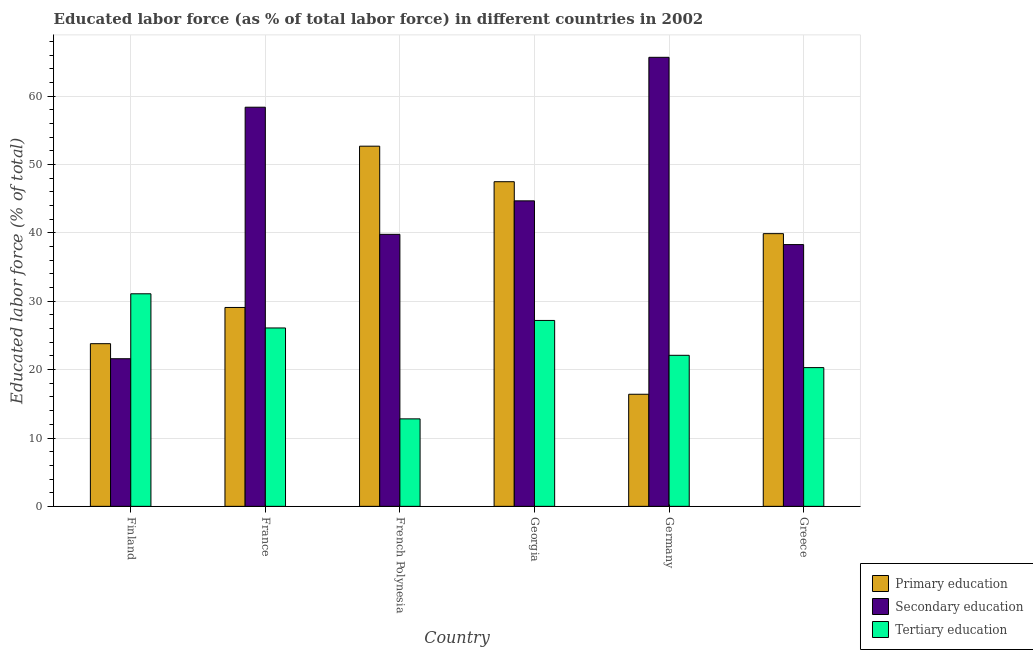How many different coloured bars are there?
Your response must be concise. 3. How many groups of bars are there?
Make the answer very short. 6. Are the number of bars on each tick of the X-axis equal?
Your response must be concise. Yes. What is the label of the 6th group of bars from the left?
Give a very brief answer. Greece. In how many cases, is the number of bars for a given country not equal to the number of legend labels?
Provide a short and direct response. 0. What is the percentage of labor force who received secondary education in French Polynesia?
Provide a short and direct response. 39.8. Across all countries, what is the maximum percentage of labor force who received primary education?
Give a very brief answer. 52.7. Across all countries, what is the minimum percentage of labor force who received secondary education?
Provide a succinct answer. 21.6. In which country was the percentage of labor force who received primary education maximum?
Offer a very short reply. French Polynesia. In which country was the percentage of labor force who received secondary education minimum?
Your response must be concise. Finland. What is the total percentage of labor force who received primary education in the graph?
Offer a terse response. 209.4. What is the difference between the percentage of labor force who received tertiary education in France and that in Georgia?
Provide a short and direct response. -1.1. What is the difference between the percentage of labor force who received tertiary education in Germany and the percentage of labor force who received primary education in Finland?
Provide a succinct answer. -1.7. What is the average percentage of labor force who received secondary education per country?
Offer a terse response. 44.75. What is the difference between the percentage of labor force who received tertiary education and percentage of labor force who received primary education in French Polynesia?
Offer a very short reply. -39.9. What is the ratio of the percentage of labor force who received secondary education in Finland to that in France?
Give a very brief answer. 0.37. What is the difference between the highest and the second highest percentage of labor force who received primary education?
Keep it short and to the point. 5.2. What is the difference between the highest and the lowest percentage of labor force who received tertiary education?
Your response must be concise. 18.3. Is the sum of the percentage of labor force who received primary education in Finland and Germany greater than the maximum percentage of labor force who received secondary education across all countries?
Provide a short and direct response. No. What does the 2nd bar from the left in France represents?
Offer a terse response. Secondary education. What does the 3rd bar from the right in Greece represents?
Provide a succinct answer. Primary education. Is it the case that in every country, the sum of the percentage of labor force who received primary education and percentage of labor force who received secondary education is greater than the percentage of labor force who received tertiary education?
Your response must be concise. Yes. How many bars are there?
Provide a succinct answer. 18. How many countries are there in the graph?
Offer a terse response. 6. What is the difference between two consecutive major ticks on the Y-axis?
Offer a terse response. 10. How are the legend labels stacked?
Your response must be concise. Vertical. What is the title of the graph?
Provide a succinct answer. Educated labor force (as % of total labor force) in different countries in 2002. Does "Ages 15-64" appear as one of the legend labels in the graph?
Your response must be concise. No. What is the label or title of the X-axis?
Provide a succinct answer. Country. What is the label or title of the Y-axis?
Give a very brief answer. Educated labor force (% of total). What is the Educated labor force (% of total) of Primary education in Finland?
Make the answer very short. 23.8. What is the Educated labor force (% of total) of Secondary education in Finland?
Make the answer very short. 21.6. What is the Educated labor force (% of total) in Tertiary education in Finland?
Offer a terse response. 31.1. What is the Educated labor force (% of total) in Primary education in France?
Provide a short and direct response. 29.1. What is the Educated labor force (% of total) in Secondary education in France?
Offer a very short reply. 58.4. What is the Educated labor force (% of total) of Tertiary education in France?
Your answer should be compact. 26.1. What is the Educated labor force (% of total) of Primary education in French Polynesia?
Give a very brief answer. 52.7. What is the Educated labor force (% of total) of Secondary education in French Polynesia?
Provide a short and direct response. 39.8. What is the Educated labor force (% of total) of Tertiary education in French Polynesia?
Keep it short and to the point. 12.8. What is the Educated labor force (% of total) of Primary education in Georgia?
Your answer should be very brief. 47.5. What is the Educated labor force (% of total) in Secondary education in Georgia?
Make the answer very short. 44.7. What is the Educated labor force (% of total) of Tertiary education in Georgia?
Give a very brief answer. 27.2. What is the Educated labor force (% of total) of Primary education in Germany?
Offer a very short reply. 16.4. What is the Educated labor force (% of total) in Secondary education in Germany?
Offer a terse response. 65.7. What is the Educated labor force (% of total) of Tertiary education in Germany?
Make the answer very short. 22.1. What is the Educated labor force (% of total) in Primary education in Greece?
Your response must be concise. 39.9. What is the Educated labor force (% of total) in Secondary education in Greece?
Give a very brief answer. 38.3. What is the Educated labor force (% of total) of Tertiary education in Greece?
Provide a succinct answer. 20.3. Across all countries, what is the maximum Educated labor force (% of total) in Primary education?
Make the answer very short. 52.7. Across all countries, what is the maximum Educated labor force (% of total) of Secondary education?
Provide a succinct answer. 65.7. Across all countries, what is the maximum Educated labor force (% of total) in Tertiary education?
Keep it short and to the point. 31.1. Across all countries, what is the minimum Educated labor force (% of total) of Primary education?
Your answer should be very brief. 16.4. Across all countries, what is the minimum Educated labor force (% of total) of Secondary education?
Keep it short and to the point. 21.6. Across all countries, what is the minimum Educated labor force (% of total) of Tertiary education?
Offer a very short reply. 12.8. What is the total Educated labor force (% of total) in Primary education in the graph?
Provide a succinct answer. 209.4. What is the total Educated labor force (% of total) of Secondary education in the graph?
Provide a short and direct response. 268.5. What is the total Educated labor force (% of total) in Tertiary education in the graph?
Offer a very short reply. 139.6. What is the difference between the Educated labor force (% of total) in Primary education in Finland and that in France?
Make the answer very short. -5.3. What is the difference between the Educated labor force (% of total) in Secondary education in Finland and that in France?
Make the answer very short. -36.8. What is the difference between the Educated labor force (% of total) in Tertiary education in Finland and that in France?
Give a very brief answer. 5. What is the difference between the Educated labor force (% of total) in Primary education in Finland and that in French Polynesia?
Provide a succinct answer. -28.9. What is the difference between the Educated labor force (% of total) of Secondary education in Finland and that in French Polynesia?
Ensure brevity in your answer.  -18.2. What is the difference between the Educated labor force (% of total) of Primary education in Finland and that in Georgia?
Offer a very short reply. -23.7. What is the difference between the Educated labor force (% of total) of Secondary education in Finland and that in Georgia?
Provide a short and direct response. -23.1. What is the difference between the Educated labor force (% of total) in Primary education in Finland and that in Germany?
Your answer should be compact. 7.4. What is the difference between the Educated labor force (% of total) of Secondary education in Finland and that in Germany?
Make the answer very short. -44.1. What is the difference between the Educated labor force (% of total) in Tertiary education in Finland and that in Germany?
Keep it short and to the point. 9. What is the difference between the Educated labor force (% of total) in Primary education in Finland and that in Greece?
Give a very brief answer. -16.1. What is the difference between the Educated labor force (% of total) in Secondary education in Finland and that in Greece?
Provide a succinct answer. -16.7. What is the difference between the Educated labor force (% of total) in Tertiary education in Finland and that in Greece?
Keep it short and to the point. 10.8. What is the difference between the Educated labor force (% of total) of Primary education in France and that in French Polynesia?
Offer a very short reply. -23.6. What is the difference between the Educated labor force (% of total) of Tertiary education in France and that in French Polynesia?
Your answer should be very brief. 13.3. What is the difference between the Educated labor force (% of total) of Primary education in France and that in Georgia?
Provide a short and direct response. -18.4. What is the difference between the Educated labor force (% of total) of Secondary education in France and that in Georgia?
Your response must be concise. 13.7. What is the difference between the Educated labor force (% of total) in Tertiary education in France and that in Georgia?
Your response must be concise. -1.1. What is the difference between the Educated labor force (% of total) of Secondary education in France and that in Germany?
Give a very brief answer. -7.3. What is the difference between the Educated labor force (% of total) of Tertiary education in France and that in Germany?
Offer a very short reply. 4. What is the difference between the Educated labor force (% of total) in Primary education in France and that in Greece?
Your answer should be compact. -10.8. What is the difference between the Educated labor force (% of total) in Secondary education in France and that in Greece?
Provide a short and direct response. 20.1. What is the difference between the Educated labor force (% of total) of Secondary education in French Polynesia and that in Georgia?
Offer a terse response. -4.9. What is the difference between the Educated labor force (% of total) of Tertiary education in French Polynesia and that in Georgia?
Provide a succinct answer. -14.4. What is the difference between the Educated labor force (% of total) in Primary education in French Polynesia and that in Germany?
Offer a terse response. 36.3. What is the difference between the Educated labor force (% of total) in Secondary education in French Polynesia and that in Germany?
Your answer should be compact. -25.9. What is the difference between the Educated labor force (% of total) of Tertiary education in French Polynesia and that in Germany?
Ensure brevity in your answer.  -9.3. What is the difference between the Educated labor force (% of total) of Primary education in French Polynesia and that in Greece?
Ensure brevity in your answer.  12.8. What is the difference between the Educated labor force (% of total) in Secondary education in French Polynesia and that in Greece?
Your response must be concise. 1.5. What is the difference between the Educated labor force (% of total) of Primary education in Georgia and that in Germany?
Offer a very short reply. 31.1. What is the difference between the Educated labor force (% of total) of Secondary education in Georgia and that in Germany?
Provide a short and direct response. -21. What is the difference between the Educated labor force (% of total) of Secondary education in Georgia and that in Greece?
Give a very brief answer. 6.4. What is the difference between the Educated labor force (% of total) in Primary education in Germany and that in Greece?
Provide a succinct answer. -23.5. What is the difference between the Educated labor force (% of total) in Secondary education in Germany and that in Greece?
Provide a short and direct response. 27.4. What is the difference between the Educated labor force (% of total) of Tertiary education in Germany and that in Greece?
Ensure brevity in your answer.  1.8. What is the difference between the Educated labor force (% of total) of Primary education in Finland and the Educated labor force (% of total) of Secondary education in France?
Provide a short and direct response. -34.6. What is the difference between the Educated labor force (% of total) of Primary education in Finland and the Educated labor force (% of total) of Tertiary education in France?
Make the answer very short. -2.3. What is the difference between the Educated labor force (% of total) of Secondary education in Finland and the Educated labor force (% of total) of Tertiary education in France?
Your response must be concise. -4.5. What is the difference between the Educated labor force (% of total) in Primary education in Finland and the Educated labor force (% of total) in Tertiary education in French Polynesia?
Provide a succinct answer. 11. What is the difference between the Educated labor force (% of total) of Primary education in Finland and the Educated labor force (% of total) of Secondary education in Georgia?
Offer a terse response. -20.9. What is the difference between the Educated labor force (% of total) of Primary education in Finland and the Educated labor force (% of total) of Tertiary education in Georgia?
Make the answer very short. -3.4. What is the difference between the Educated labor force (% of total) of Primary education in Finland and the Educated labor force (% of total) of Secondary education in Germany?
Your answer should be compact. -41.9. What is the difference between the Educated labor force (% of total) of Primary education in Finland and the Educated labor force (% of total) of Tertiary education in Germany?
Offer a very short reply. 1.7. What is the difference between the Educated labor force (% of total) of Primary education in Finland and the Educated labor force (% of total) of Tertiary education in Greece?
Provide a succinct answer. 3.5. What is the difference between the Educated labor force (% of total) of Primary education in France and the Educated labor force (% of total) of Tertiary education in French Polynesia?
Make the answer very short. 16.3. What is the difference between the Educated labor force (% of total) of Secondary education in France and the Educated labor force (% of total) of Tertiary education in French Polynesia?
Give a very brief answer. 45.6. What is the difference between the Educated labor force (% of total) in Primary education in France and the Educated labor force (% of total) in Secondary education in Georgia?
Your response must be concise. -15.6. What is the difference between the Educated labor force (% of total) of Secondary education in France and the Educated labor force (% of total) of Tertiary education in Georgia?
Make the answer very short. 31.2. What is the difference between the Educated labor force (% of total) of Primary education in France and the Educated labor force (% of total) of Secondary education in Germany?
Your answer should be compact. -36.6. What is the difference between the Educated labor force (% of total) in Secondary education in France and the Educated labor force (% of total) in Tertiary education in Germany?
Keep it short and to the point. 36.3. What is the difference between the Educated labor force (% of total) of Primary education in France and the Educated labor force (% of total) of Tertiary education in Greece?
Your answer should be very brief. 8.8. What is the difference between the Educated labor force (% of total) in Secondary education in France and the Educated labor force (% of total) in Tertiary education in Greece?
Ensure brevity in your answer.  38.1. What is the difference between the Educated labor force (% of total) in Primary education in French Polynesia and the Educated labor force (% of total) in Secondary education in Georgia?
Your answer should be very brief. 8. What is the difference between the Educated labor force (% of total) in Primary education in French Polynesia and the Educated labor force (% of total) in Tertiary education in Georgia?
Your answer should be compact. 25.5. What is the difference between the Educated labor force (% of total) in Primary education in French Polynesia and the Educated labor force (% of total) in Tertiary education in Germany?
Your response must be concise. 30.6. What is the difference between the Educated labor force (% of total) in Primary education in French Polynesia and the Educated labor force (% of total) in Tertiary education in Greece?
Provide a short and direct response. 32.4. What is the difference between the Educated labor force (% of total) in Secondary education in French Polynesia and the Educated labor force (% of total) in Tertiary education in Greece?
Keep it short and to the point. 19.5. What is the difference between the Educated labor force (% of total) of Primary education in Georgia and the Educated labor force (% of total) of Secondary education in Germany?
Provide a succinct answer. -18.2. What is the difference between the Educated labor force (% of total) in Primary education in Georgia and the Educated labor force (% of total) in Tertiary education in Germany?
Provide a succinct answer. 25.4. What is the difference between the Educated labor force (% of total) of Secondary education in Georgia and the Educated labor force (% of total) of Tertiary education in Germany?
Give a very brief answer. 22.6. What is the difference between the Educated labor force (% of total) in Primary education in Georgia and the Educated labor force (% of total) in Tertiary education in Greece?
Give a very brief answer. 27.2. What is the difference between the Educated labor force (% of total) in Secondary education in Georgia and the Educated labor force (% of total) in Tertiary education in Greece?
Give a very brief answer. 24.4. What is the difference between the Educated labor force (% of total) in Primary education in Germany and the Educated labor force (% of total) in Secondary education in Greece?
Your answer should be very brief. -21.9. What is the difference between the Educated labor force (% of total) of Secondary education in Germany and the Educated labor force (% of total) of Tertiary education in Greece?
Provide a succinct answer. 45.4. What is the average Educated labor force (% of total) in Primary education per country?
Make the answer very short. 34.9. What is the average Educated labor force (% of total) in Secondary education per country?
Offer a very short reply. 44.75. What is the average Educated labor force (% of total) of Tertiary education per country?
Provide a succinct answer. 23.27. What is the difference between the Educated labor force (% of total) in Primary education and Educated labor force (% of total) in Secondary education in Finland?
Give a very brief answer. 2.2. What is the difference between the Educated labor force (% of total) of Primary education and Educated labor force (% of total) of Secondary education in France?
Give a very brief answer. -29.3. What is the difference between the Educated labor force (% of total) in Secondary education and Educated labor force (% of total) in Tertiary education in France?
Give a very brief answer. 32.3. What is the difference between the Educated labor force (% of total) of Primary education and Educated labor force (% of total) of Tertiary education in French Polynesia?
Your answer should be compact. 39.9. What is the difference between the Educated labor force (% of total) of Secondary education and Educated labor force (% of total) of Tertiary education in French Polynesia?
Provide a succinct answer. 27. What is the difference between the Educated labor force (% of total) of Primary education and Educated labor force (% of total) of Secondary education in Georgia?
Your answer should be very brief. 2.8. What is the difference between the Educated labor force (% of total) of Primary education and Educated labor force (% of total) of Tertiary education in Georgia?
Provide a short and direct response. 20.3. What is the difference between the Educated labor force (% of total) in Secondary education and Educated labor force (% of total) in Tertiary education in Georgia?
Give a very brief answer. 17.5. What is the difference between the Educated labor force (% of total) in Primary education and Educated labor force (% of total) in Secondary education in Germany?
Make the answer very short. -49.3. What is the difference between the Educated labor force (% of total) in Secondary education and Educated labor force (% of total) in Tertiary education in Germany?
Keep it short and to the point. 43.6. What is the difference between the Educated labor force (% of total) of Primary education and Educated labor force (% of total) of Secondary education in Greece?
Make the answer very short. 1.6. What is the difference between the Educated labor force (% of total) in Primary education and Educated labor force (% of total) in Tertiary education in Greece?
Provide a succinct answer. 19.6. What is the difference between the Educated labor force (% of total) in Secondary education and Educated labor force (% of total) in Tertiary education in Greece?
Provide a succinct answer. 18. What is the ratio of the Educated labor force (% of total) in Primary education in Finland to that in France?
Keep it short and to the point. 0.82. What is the ratio of the Educated labor force (% of total) in Secondary education in Finland to that in France?
Make the answer very short. 0.37. What is the ratio of the Educated labor force (% of total) of Tertiary education in Finland to that in France?
Make the answer very short. 1.19. What is the ratio of the Educated labor force (% of total) in Primary education in Finland to that in French Polynesia?
Give a very brief answer. 0.45. What is the ratio of the Educated labor force (% of total) in Secondary education in Finland to that in French Polynesia?
Ensure brevity in your answer.  0.54. What is the ratio of the Educated labor force (% of total) of Tertiary education in Finland to that in French Polynesia?
Ensure brevity in your answer.  2.43. What is the ratio of the Educated labor force (% of total) of Primary education in Finland to that in Georgia?
Ensure brevity in your answer.  0.5. What is the ratio of the Educated labor force (% of total) of Secondary education in Finland to that in Georgia?
Make the answer very short. 0.48. What is the ratio of the Educated labor force (% of total) of Tertiary education in Finland to that in Georgia?
Provide a succinct answer. 1.14. What is the ratio of the Educated labor force (% of total) in Primary education in Finland to that in Germany?
Offer a terse response. 1.45. What is the ratio of the Educated labor force (% of total) of Secondary education in Finland to that in Germany?
Ensure brevity in your answer.  0.33. What is the ratio of the Educated labor force (% of total) of Tertiary education in Finland to that in Germany?
Offer a very short reply. 1.41. What is the ratio of the Educated labor force (% of total) in Primary education in Finland to that in Greece?
Ensure brevity in your answer.  0.6. What is the ratio of the Educated labor force (% of total) of Secondary education in Finland to that in Greece?
Your answer should be compact. 0.56. What is the ratio of the Educated labor force (% of total) of Tertiary education in Finland to that in Greece?
Provide a succinct answer. 1.53. What is the ratio of the Educated labor force (% of total) of Primary education in France to that in French Polynesia?
Your answer should be very brief. 0.55. What is the ratio of the Educated labor force (% of total) in Secondary education in France to that in French Polynesia?
Your answer should be compact. 1.47. What is the ratio of the Educated labor force (% of total) in Tertiary education in France to that in French Polynesia?
Make the answer very short. 2.04. What is the ratio of the Educated labor force (% of total) in Primary education in France to that in Georgia?
Provide a short and direct response. 0.61. What is the ratio of the Educated labor force (% of total) in Secondary education in France to that in Georgia?
Provide a short and direct response. 1.31. What is the ratio of the Educated labor force (% of total) in Tertiary education in France to that in Georgia?
Your response must be concise. 0.96. What is the ratio of the Educated labor force (% of total) in Primary education in France to that in Germany?
Provide a short and direct response. 1.77. What is the ratio of the Educated labor force (% of total) of Secondary education in France to that in Germany?
Provide a short and direct response. 0.89. What is the ratio of the Educated labor force (% of total) of Tertiary education in France to that in Germany?
Your answer should be very brief. 1.18. What is the ratio of the Educated labor force (% of total) of Primary education in France to that in Greece?
Make the answer very short. 0.73. What is the ratio of the Educated labor force (% of total) of Secondary education in France to that in Greece?
Make the answer very short. 1.52. What is the ratio of the Educated labor force (% of total) in Tertiary education in France to that in Greece?
Your answer should be compact. 1.29. What is the ratio of the Educated labor force (% of total) of Primary education in French Polynesia to that in Georgia?
Ensure brevity in your answer.  1.11. What is the ratio of the Educated labor force (% of total) of Secondary education in French Polynesia to that in Georgia?
Provide a short and direct response. 0.89. What is the ratio of the Educated labor force (% of total) in Tertiary education in French Polynesia to that in Georgia?
Provide a succinct answer. 0.47. What is the ratio of the Educated labor force (% of total) of Primary education in French Polynesia to that in Germany?
Give a very brief answer. 3.21. What is the ratio of the Educated labor force (% of total) in Secondary education in French Polynesia to that in Germany?
Offer a terse response. 0.61. What is the ratio of the Educated labor force (% of total) in Tertiary education in French Polynesia to that in Germany?
Give a very brief answer. 0.58. What is the ratio of the Educated labor force (% of total) of Primary education in French Polynesia to that in Greece?
Keep it short and to the point. 1.32. What is the ratio of the Educated labor force (% of total) in Secondary education in French Polynesia to that in Greece?
Your response must be concise. 1.04. What is the ratio of the Educated labor force (% of total) of Tertiary education in French Polynesia to that in Greece?
Provide a succinct answer. 0.63. What is the ratio of the Educated labor force (% of total) of Primary education in Georgia to that in Germany?
Offer a terse response. 2.9. What is the ratio of the Educated labor force (% of total) of Secondary education in Georgia to that in Germany?
Give a very brief answer. 0.68. What is the ratio of the Educated labor force (% of total) of Tertiary education in Georgia to that in Germany?
Your answer should be compact. 1.23. What is the ratio of the Educated labor force (% of total) of Primary education in Georgia to that in Greece?
Give a very brief answer. 1.19. What is the ratio of the Educated labor force (% of total) of Secondary education in Georgia to that in Greece?
Provide a succinct answer. 1.17. What is the ratio of the Educated labor force (% of total) of Tertiary education in Georgia to that in Greece?
Offer a terse response. 1.34. What is the ratio of the Educated labor force (% of total) of Primary education in Germany to that in Greece?
Keep it short and to the point. 0.41. What is the ratio of the Educated labor force (% of total) of Secondary education in Germany to that in Greece?
Offer a very short reply. 1.72. What is the ratio of the Educated labor force (% of total) of Tertiary education in Germany to that in Greece?
Provide a succinct answer. 1.09. What is the difference between the highest and the second highest Educated labor force (% of total) of Secondary education?
Provide a short and direct response. 7.3. What is the difference between the highest and the lowest Educated labor force (% of total) in Primary education?
Offer a very short reply. 36.3. What is the difference between the highest and the lowest Educated labor force (% of total) of Secondary education?
Ensure brevity in your answer.  44.1. What is the difference between the highest and the lowest Educated labor force (% of total) in Tertiary education?
Your response must be concise. 18.3. 